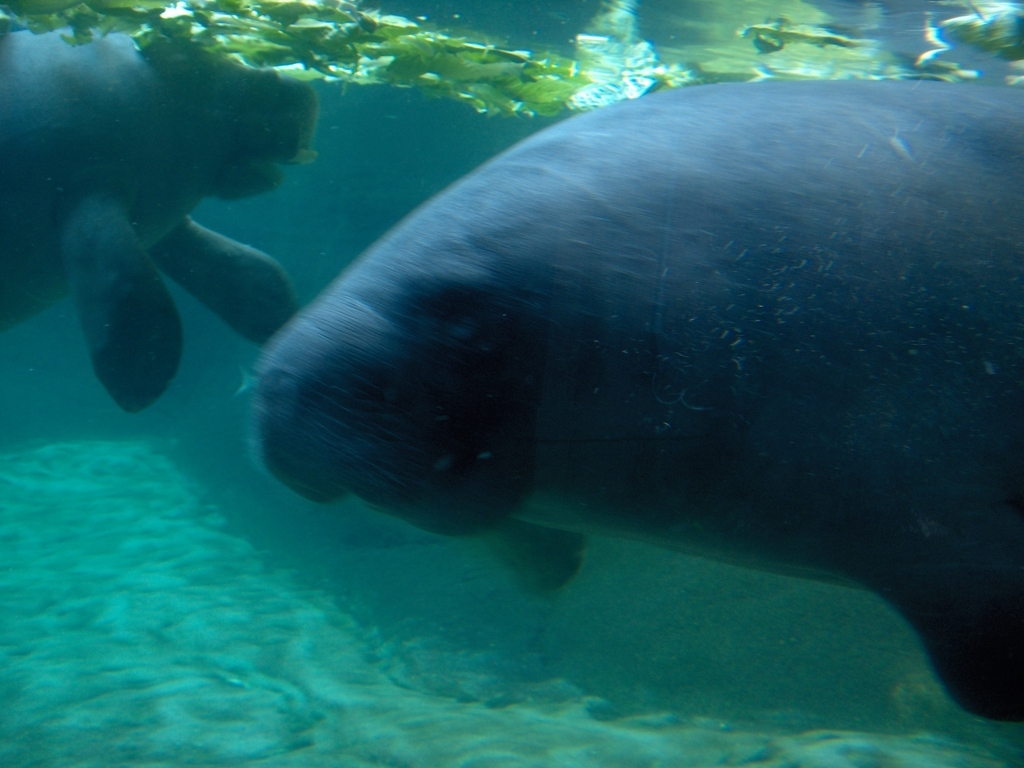Why might the image be taken in this way? The image may have been taken through a glass panel of an aquarium or using an underwater camera in the wild to minimize disturbance to the manatees and to provide a clear view of their behavior in a natural setting. 